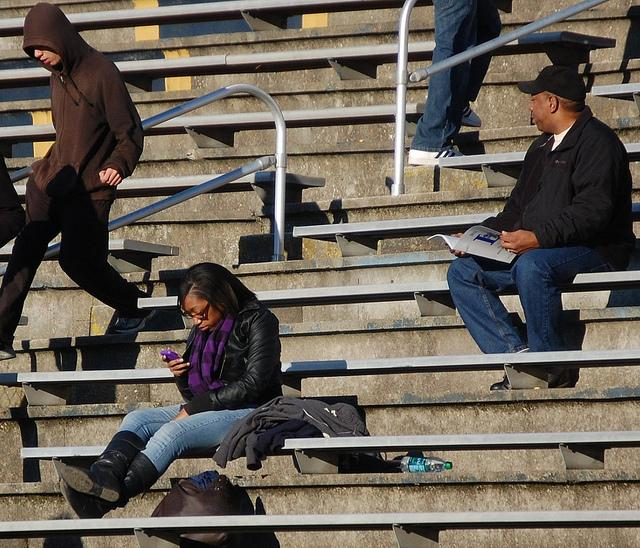What are the people sitting on? bleachers 